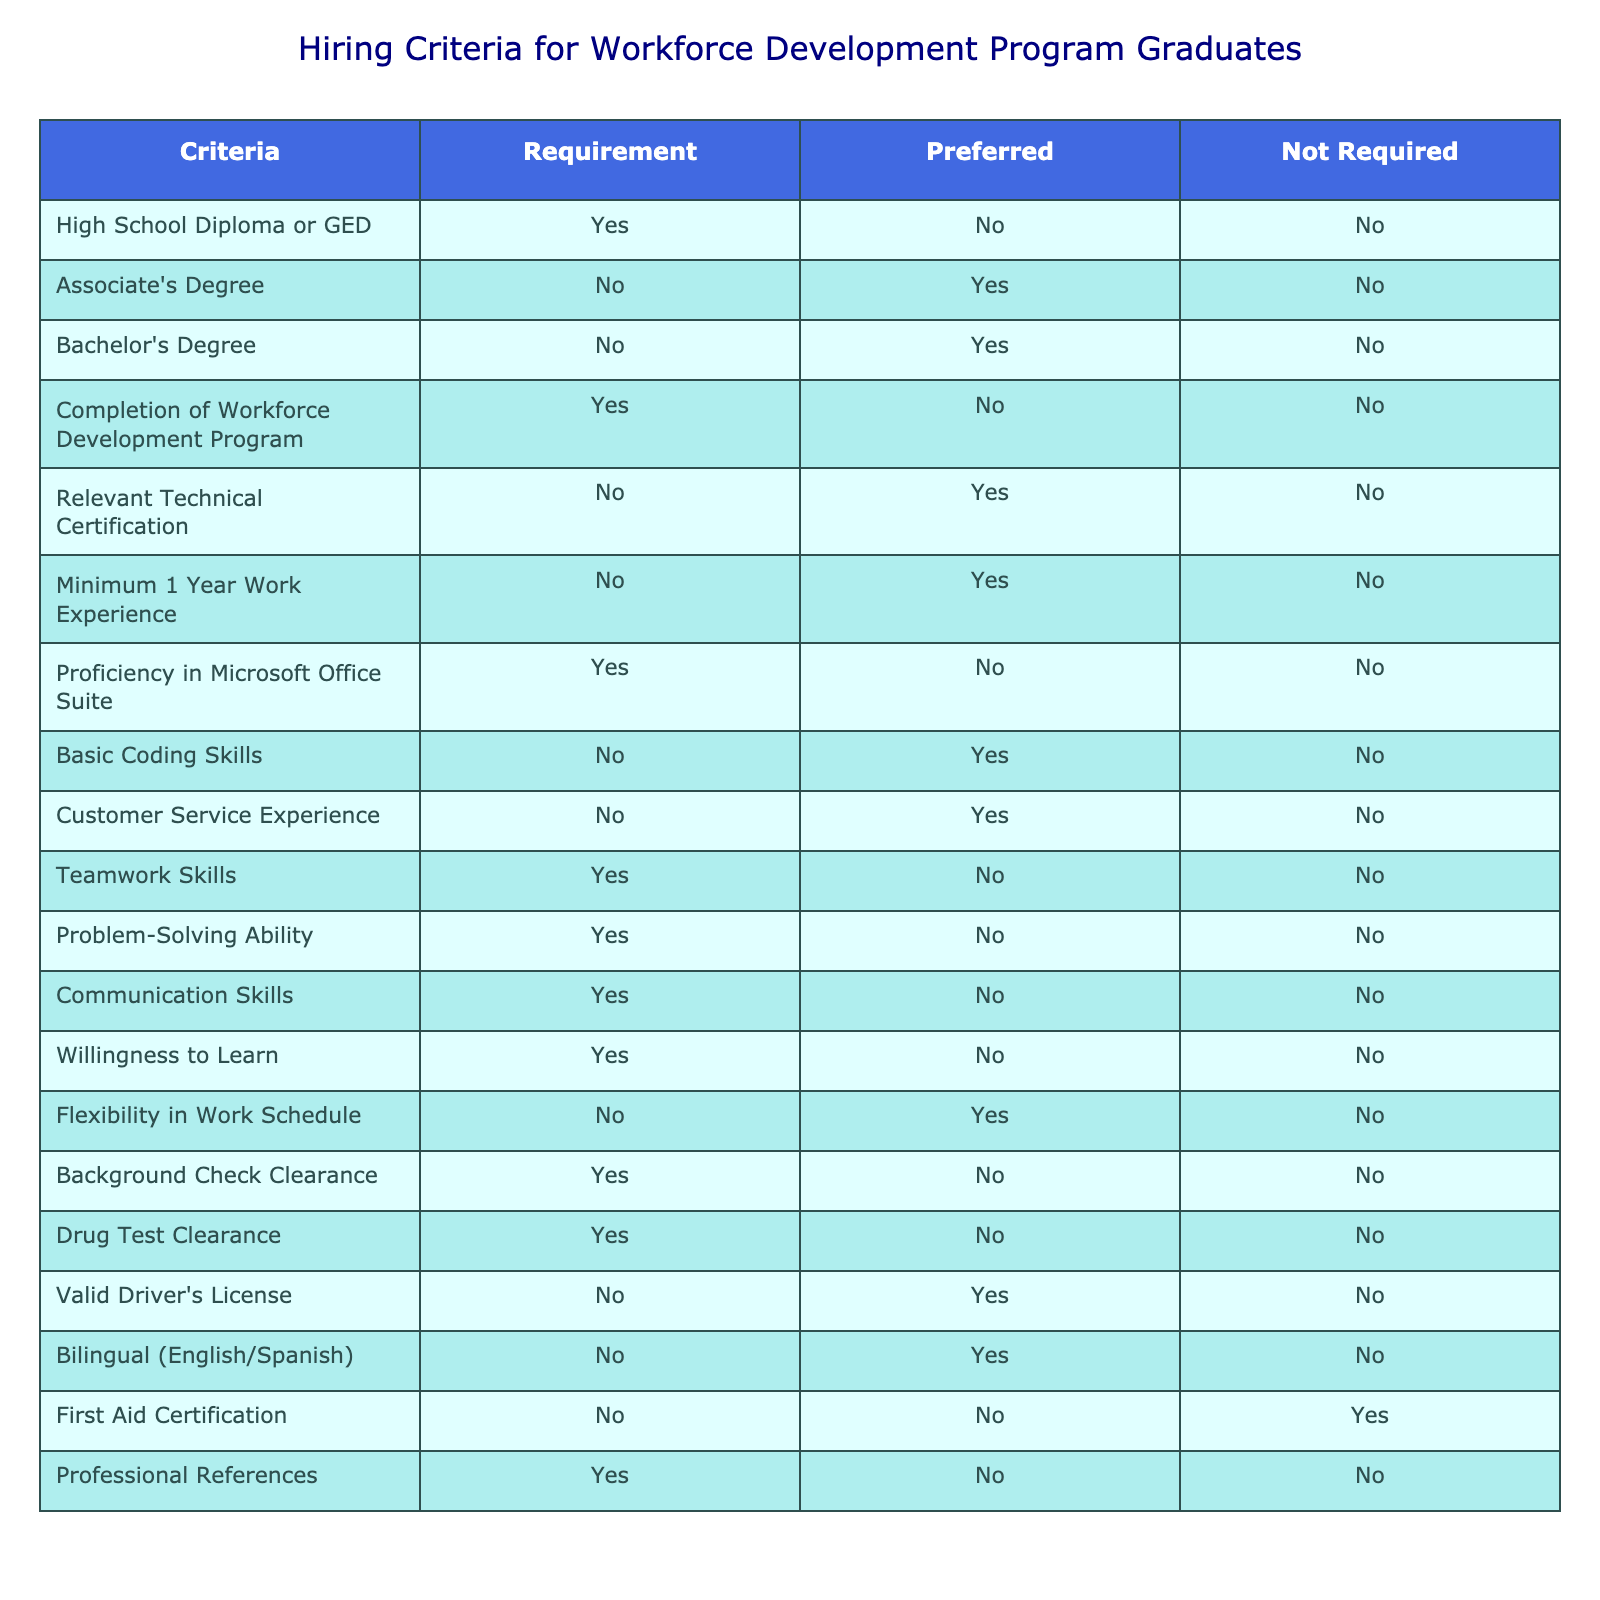What educational qualification is a requirement for the program graduates? The table specifies that a High School Diploma or GED is a required qualification for program graduates. Thus, the answer is directly obtained from the “Requirement” column under the relevant criteria.
Answer: High School Diploma or GED How many criteria have a bachelor's degree as a preferred qualification? The table indicates that a Bachelor's Degree is listed as a preferred qualification. To find how many criteria have it listed as preferred, we look at the entries under the "Preferred" column and identify this specific criteria, where it appears once.
Answer: 1 Is a valid driver's license required for program graduates? According to the table, a valid driver's license is marked as "No" under the "Requirement" column. This indicates that having a valid driver's license is not a requirement for program graduates.
Answer: No What is the total number of criteria that are required for program graduates? To find the total number of required criteria, we can count all the entries in the "Requirement" column that have "Yes" marked. From the table, there are 6 criteria with "Yes" under the "Requirement."
Answer: 6 Are professional references a mandatory qualification for program graduates? The table shows that professional references are listed with a "Yes" under the "Requirement" column, indicating that they are mandatory for program graduates.
Answer: Yes What percentage of the criteria relate to technical skills? In the table, we count the criteria related to technical skills, which includes the criteria such as Relevant Technical Certification, Basic Coding Skills, and Proficiency in Microsoft Office Suite. There are 4 out of a total of 15 criteria that relate to technical skills, so we calculate the percentage: (4/15) * 100 = 26.67%.
Answer: 26.67% How many criteria have both a requirement and preferred status? By examining the table, we check each criterion for status marked with "Yes" in both "Requirement" and "Preferred" columns. This situation is not possible since "Yes" appears only once per criterion in the "Requirement" category. Hence, there are zero instances.
Answer: 0 What skills are required for the program graduates? The table shows specific skills that are marked as required: Teamwork Skills, Problem-Solving Ability, Communication Skills, and a willingness to learn. We gather these criteria from the “Requirement” column marked "Yes." Hence, there are four required skills mentioned specifically.
Answer: 4 skills How many criteria are preferred but not required? By counting the total number of criteria with "Yes" in the "Preferred" column while ensuring they are "No" under "Requirement," we find there are 10 criteria that fall into this category.
Answer: 10 